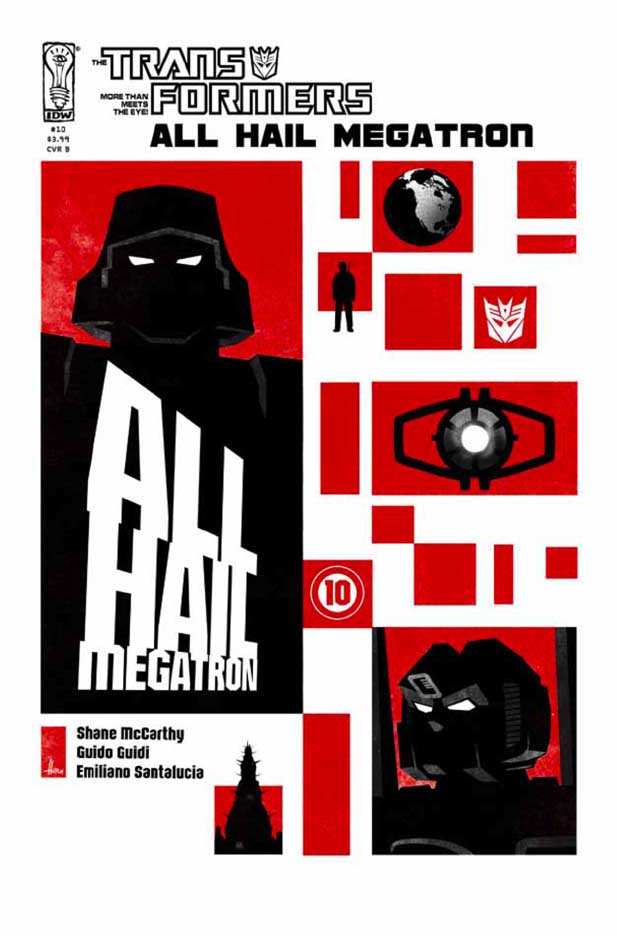Why do you think the creators chose the bold command 'ALL HAIL MEGATRON' for the title? The creators likely chose the bold command 'ALL HAIL MEGATRON' for its strong, authoritative connotation, immediately establishing the central role of Megatron in this storyline. This phrase commands attention and conveys a sense of domination and reverence, implying that Megatron’s power is unchallenged or that he has achieved a significant victory. It sets a dramatic and imposing tone, indicating that the comic will revolve around his actions and influence, likely portraying a narrative arc where his authority is unquestioned and his presence pivotal to the unfolding events. 